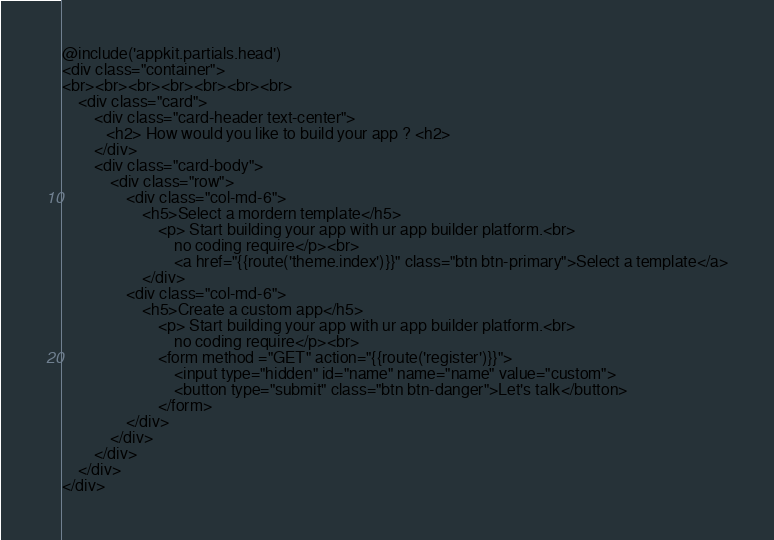<code> <loc_0><loc_0><loc_500><loc_500><_PHP_>@include('appkit.partials.head')
<div class="container">
<br><br><br><br><br><br><br>
    <div class="card">
        <div class="card-header text-center">
           <h2> How would you like to build your app ? <h2>
        </div>
        <div class="card-body">
            <div class="row">
                <div class="col-md-6">
                    <h5>Select a mordern template</h5>
                        <p> Start building your app with ur app builder platform.<br>
                            no coding require</p><br>
                            <a href="{{route('theme.index')}}" class="btn btn-primary">Select a template</a>
                    </div>
                <div class="col-md-6">
                    <h5>Create a custom app</h5>
                        <p> Start building your app with ur app builder platform.<br>
                            no coding require</p><br>
                        <form method ="GET" action="{{route('register')}}">
                            <input type="hidden" id="name" name="name" value="custom">
                            <button type="submit" class="btn btn-danger">Let's talk</button>
                        </form>
                </div>
            </div>
        </div>
    </div>
</div>
</code> 